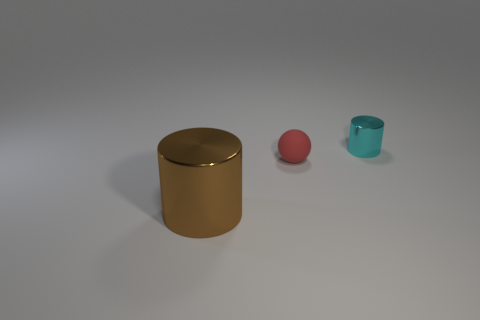There is a thing that is to the right of the large brown metallic thing and left of the tiny cyan cylinder; how big is it? The object in question appears to be a small pink ball. It is significantly smaller than the large brown cylindrical object to its left and slightly larger in comparison to the tiny cyan cylinder to its right. 